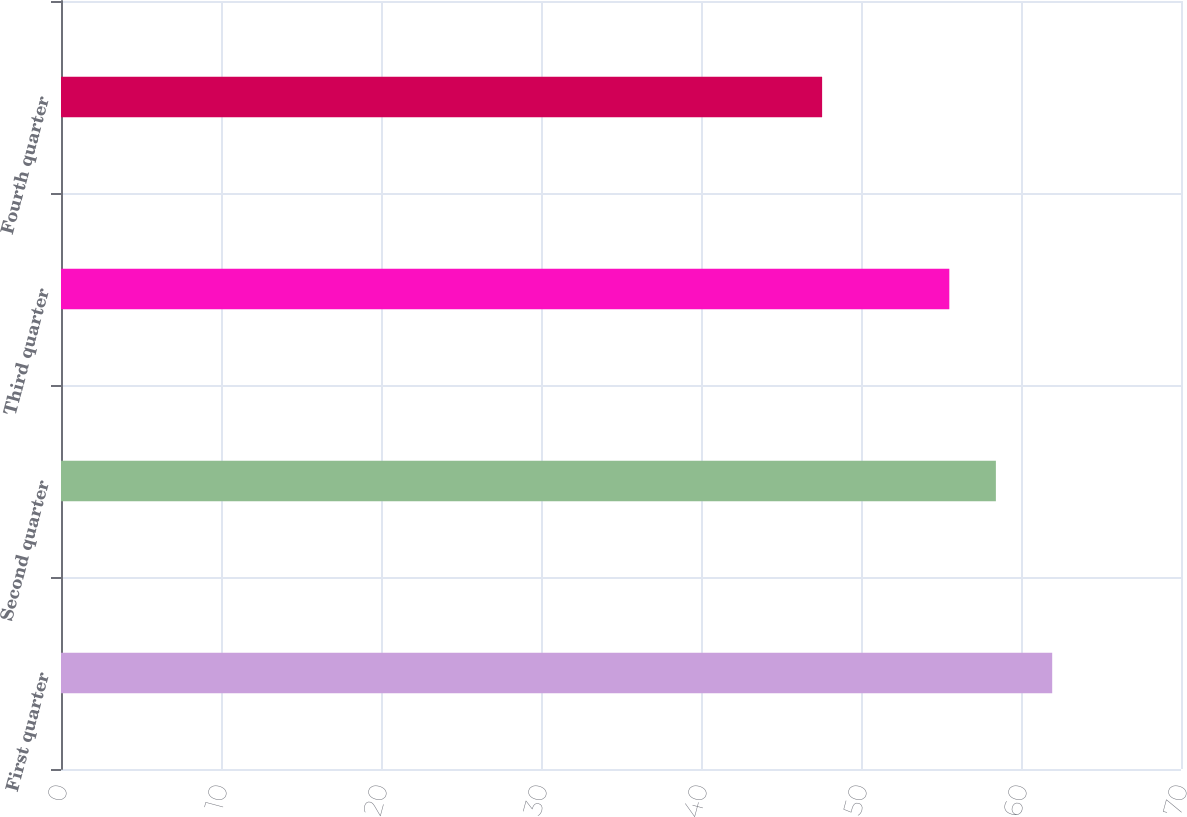Convert chart to OTSL. <chart><loc_0><loc_0><loc_500><loc_500><bar_chart><fcel>First quarter<fcel>Second quarter<fcel>Third quarter<fcel>Fourth quarter<nl><fcel>61.95<fcel>58.43<fcel>55.52<fcel>47.57<nl></chart> 